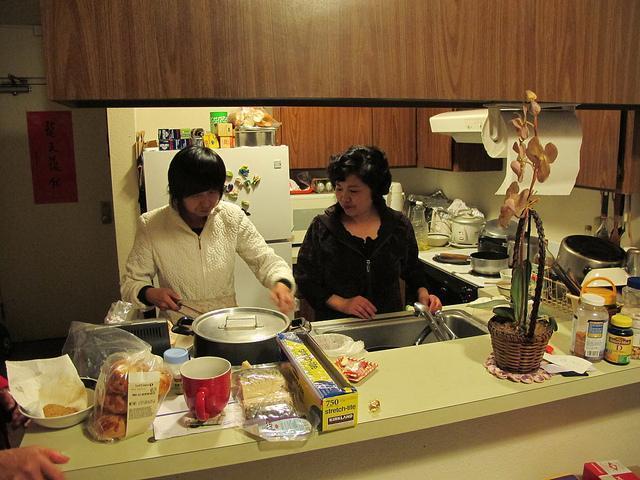How many friends?
Give a very brief answer. 2. How many people can you see?
Give a very brief answer. 3. How many cups are in the picture?
Give a very brief answer. 1. How many boats are moving in the photo?
Give a very brief answer. 0. 